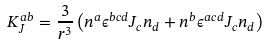Convert formula to latex. <formula><loc_0><loc_0><loc_500><loc_500>K ^ { a b } _ { J } = \frac { 3 } { r ^ { 3 } } \left ( n ^ { a } \epsilon ^ { b c d } J _ { c } n _ { d } + n ^ { b } \epsilon ^ { a c d } J _ { c } n _ { d } \right )</formula> 